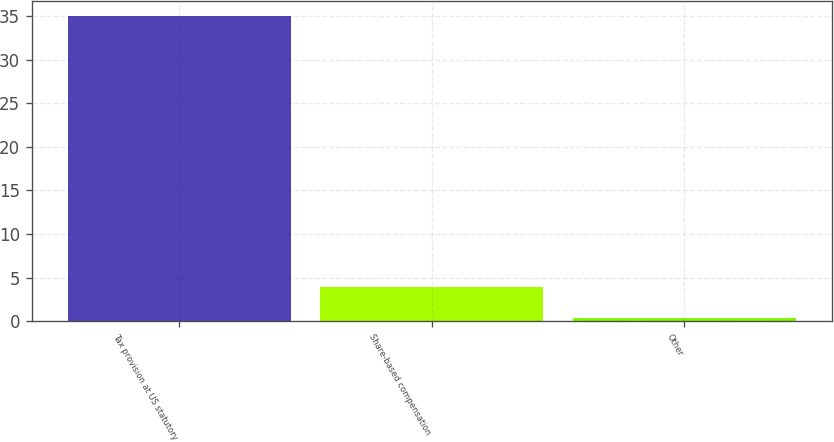Convert chart. <chart><loc_0><loc_0><loc_500><loc_500><bar_chart><fcel>Tax provision at US statutory<fcel>Share-based compensation<fcel>Other<nl><fcel>35<fcel>3.86<fcel>0.4<nl></chart> 